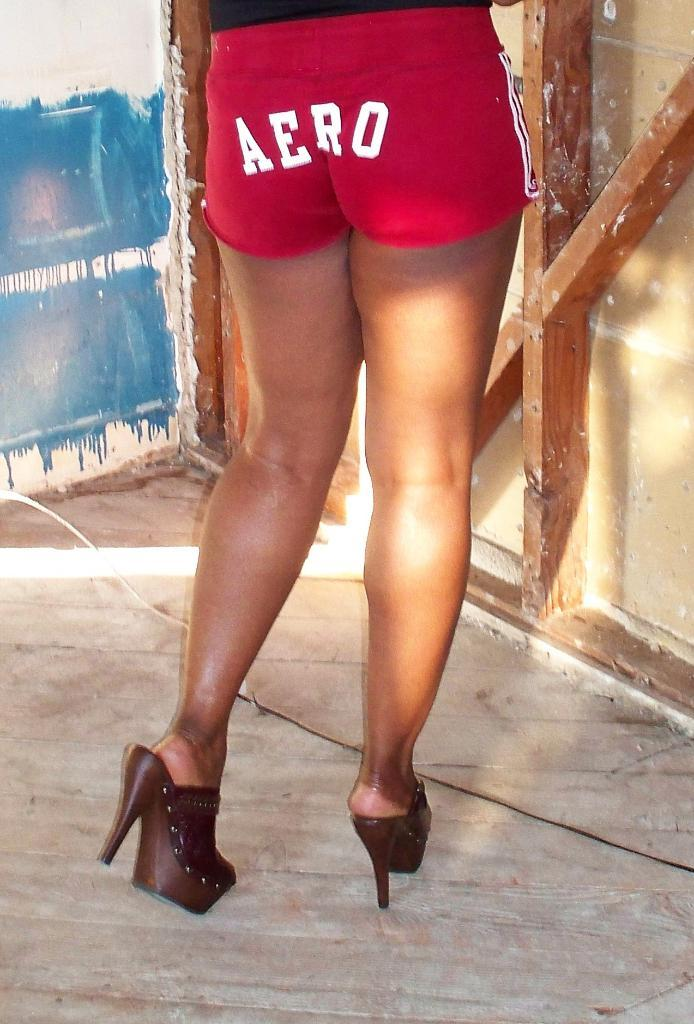Provide a one-sentence caption for the provided image. A woman from the waist down is wearing red shorts with the word AERO across her butt with high heeled sandals. 